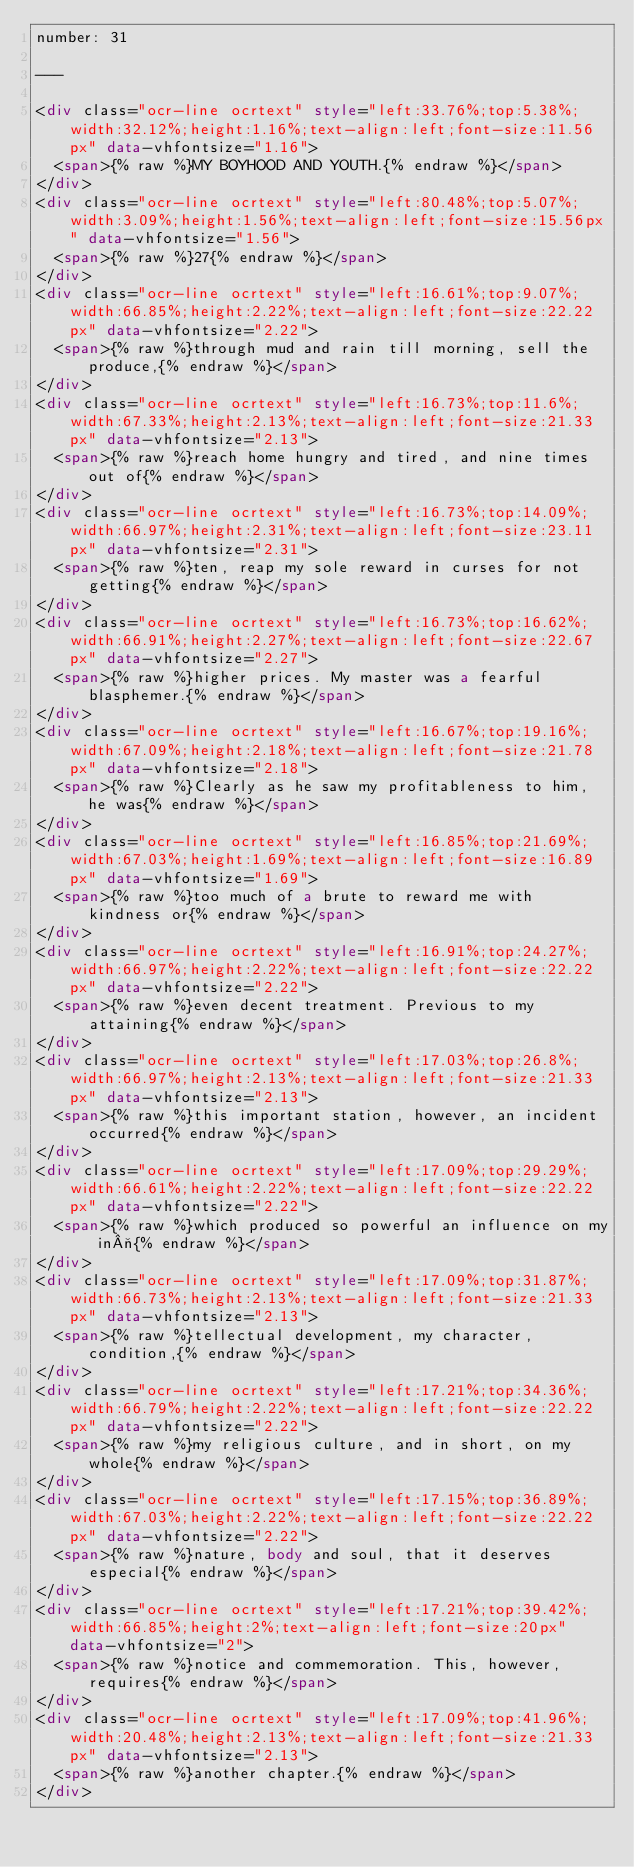<code> <loc_0><loc_0><loc_500><loc_500><_HTML_>number: 31

---

<div class="ocr-line ocrtext" style="left:33.76%;top:5.38%;width:32.12%;height:1.16%;text-align:left;font-size:11.56px" data-vhfontsize="1.16">
  <span>{% raw %}MY BOYHOOD AND YOUTH.{% endraw %}</span>
</div>
<div class="ocr-line ocrtext" style="left:80.48%;top:5.07%;width:3.09%;height:1.56%;text-align:left;font-size:15.56px" data-vhfontsize="1.56">
  <span>{% raw %}27{% endraw %}</span>
</div>
<div class="ocr-line ocrtext" style="left:16.61%;top:9.07%;width:66.85%;height:2.22%;text-align:left;font-size:22.22px" data-vhfontsize="2.22">
  <span>{% raw %}through mud and rain till morning, sell the produce,{% endraw %}</span>
</div>
<div class="ocr-line ocrtext" style="left:16.73%;top:11.6%;width:67.33%;height:2.13%;text-align:left;font-size:21.33px" data-vhfontsize="2.13">
  <span>{% raw %}reach home hungry and tired, and nine times out of{% endraw %}</span>
</div>
<div class="ocr-line ocrtext" style="left:16.73%;top:14.09%;width:66.97%;height:2.31%;text-align:left;font-size:23.11px" data-vhfontsize="2.31">
  <span>{% raw %}ten, reap my sole reward in curses for not getting{% endraw %}</span>
</div>
<div class="ocr-line ocrtext" style="left:16.73%;top:16.62%;width:66.91%;height:2.27%;text-align:left;font-size:22.67px" data-vhfontsize="2.27">
  <span>{% raw %}higher prices. My master was a fearful blasphemer.{% endraw %}</span>
</div>
<div class="ocr-line ocrtext" style="left:16.67%;top:19.16%;width:67.09%;height:2.18%;text-align:left;font-size:21.78px" data-vhfontsize="2.18">
  <span>{% raw %}Clearly as he saw my profitableness to him, he was{% endraw %}</span>
</div>
<div class="ocr-line ocrtext" style="left:16.85%;top:21.69%;width:67.03%;height:1.69%;text-align:left;font-size:16.89px" data-vhfontsize="1.69">
  <span>{% raw %}too much of a brute to reward me with kindness or{% endraw %}</span>
</div>
<div class="ocr-line ocrtext" style="left:16.91%;top:24.27%;width:66.97%;height:2.22%;text-align:left;font-size:22.22px" data-vhfontsize="2.22">
  <span>{% raw %}even decent treatment. Previous to my attaining{% endraw %}</span>
</div>
<div class="ocr-line ocrtext" style="left:17.03%;top:26.8%;width:66.97%;height:2.13%;text-align:left;font-size:21.33px" data-vhfontsize="2.13">
  <span>{% raw %}this important station, however, an incident occurred{% endraw %}</span>
</div>
<div class="ocr-line ocrtext" style="left:17.09%;top:29.29%;width:66.61%;height:2.22%;text-align:left;font-size:22.22px" data-vhfontsize="2.22">
  <span>{% raw %}which produced so powerful an influence on my in¬{% endraw %}</span>
</div>
<div class="ocr-line ocrtext" style="left:17.09%;top:31.87%;width:66.73%;height:2.13%;text-align:left;font-size:21.33px" data-vhfontsize="2.13">
  <span>{% raw %}tellectual development, my character, condition,{% endraw %}</span>
</div>
<div class="ocr-line ocrtext" style="left:17.21%;top:34.36%;width:66.79%;height:2.22%;text-align:left;font-size:22.22px" data-vhfontsize="2.22">
  <span>{% raw %}my religious culture, and in short, on my whole{% endraw %}</span>
</div>
<div class="ocr-line ocrtext" style="left:17.15%;top:36.89%;width:67.03%;height:2.22%;text-align:left;font-size:22.22px" data-vhfontsize="2.22">
  <span>{% raw %}nature, body and soul, that it deserves especial{% endraw %}</span>
</div>
<div class="ocr-line ocrtext" style="left:17.21%;top:39.42%;width:66.85%;height:2%;text-align:left;font-size:20px" data-vhfontsize="2">
  <span>{% raw %}notice and commemoration. This, however, requires{% endraw %}</span>
</div>
<div class="ocr-line ocrtext" style="left:17.09%;top:41.96%;width:20.48%;height:2.13%;text-align:left;font-size:21.33px" data-vhfontsize="2.13">
  <span>{% raw %}another chapter.{% endraw %}</span>
</div>
</code> 